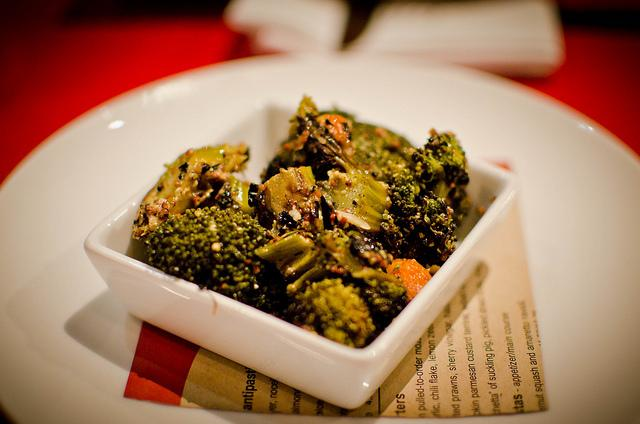What shape is the small plate? square 